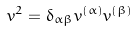<formula> <loc_0><loc_0><loc_500><loc_500>v ^ { 2 } = \delta _ { \alpha \beta } v ^ { ( \alpha ) } v ^ { ( \beta ) }</formula> 